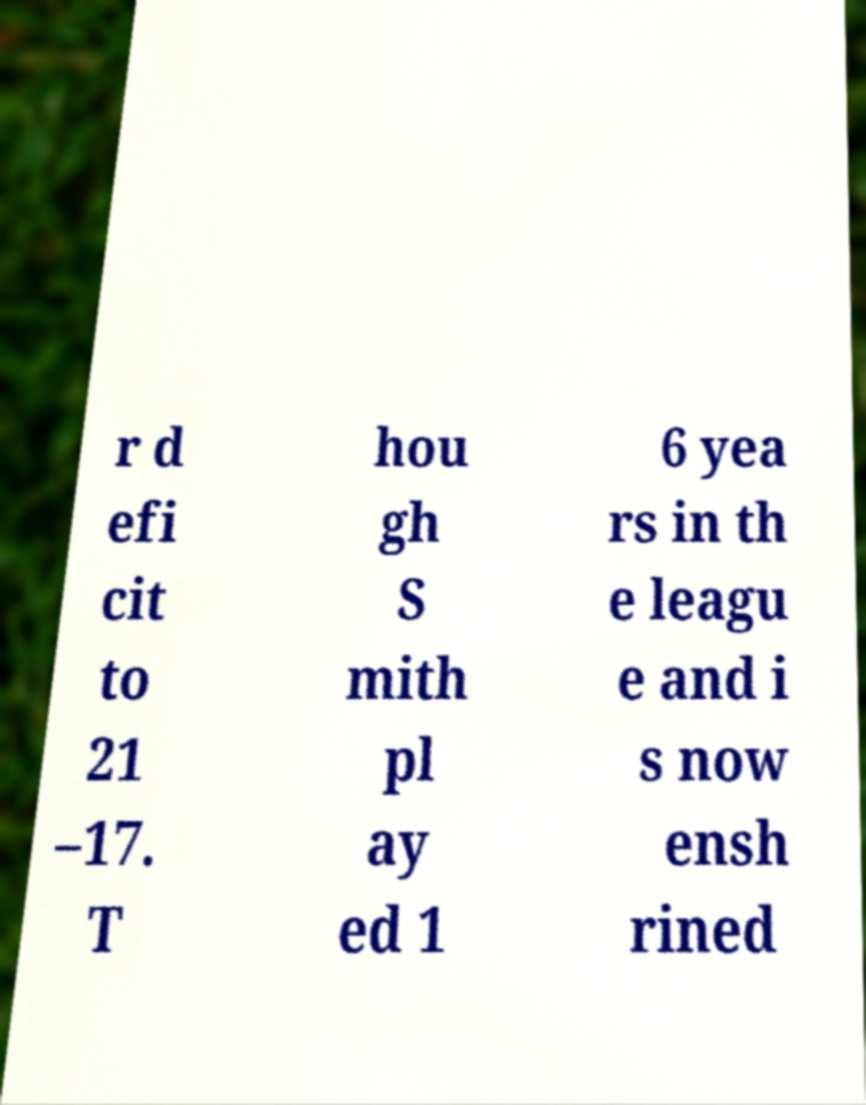Could you assist in decoding the text presented in this image and type it out clearly? r d efi cit to 21 –17. T hou gh S mith pl ay ed 1 6 yea rs in th e leagu e and i s now ensh rined 